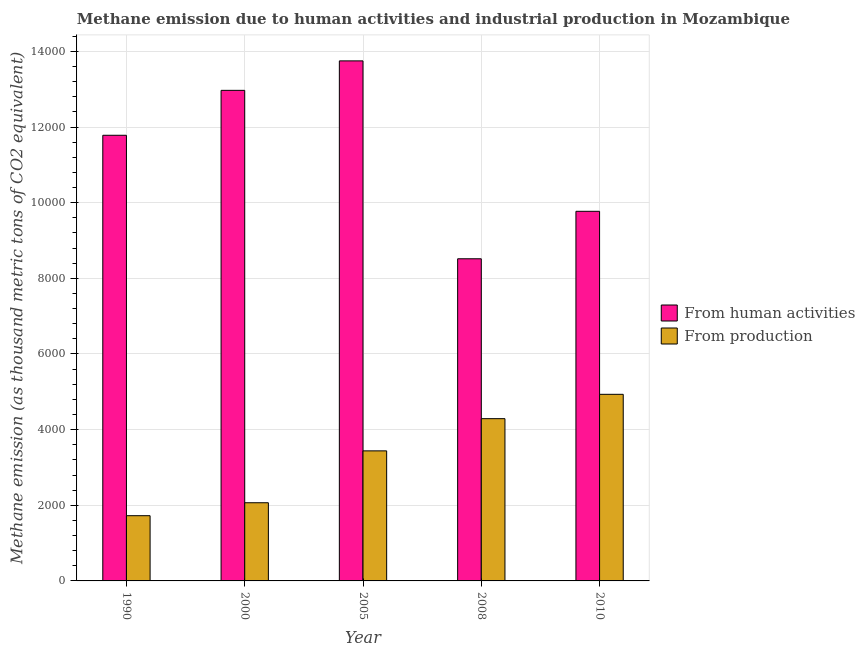How many different coloured bars are there?
Ensure brevity in your answer.  2. Are the number of bars per tick equal to the number of legend labels?
Your response must be concise. Yes. Are the number of bars on each tick of the X-axis equal?
Offer a terse response. Yes. How many bars are there on the 4th tick from the right?
Offer a very short reply. 2. In how many cases, is the number of bars for a given year not equal to the number of legend labels?
Your answer should be compact. 0. What is the amount of emissions from human activities in 1990?
Keep it short and to the point. 1.18e+04. Across all years, what is the maximum amount of emissions from human activities?
Offer a very short reply. 1.37e+04. Across all years, what is the minimum amount of emissions from human activities?
Provide a short and direct response. 8517.4. What is the total amount of emissions generated from industries in the graph?
Your response must be concise. 1.65e+04. What is the difference between the amount of emissions generated from industries in 1990 and that in 2008?
Provide a succinct answer. -2565.3. What is the difference between the amount of emissions from human activities in 2008 and the amount of emissions generated from industries in 2010?
Your answer should be very brief. -1255. What is the average amount of emissions from human activities per year?
Your answer should be very brief. 1.14e+04. In how many years, is the amount of emissions from human activities greater than 12000 thousand metric tons?
Provide a short and direct response. 2. What is the ratio of the amount of emissions from human activities in 1990 to that in 2008?
Provide a short and direct response. 1.38. Is the difference between the amount of emissions generated from industries in 2005 and 2010 greater than the difference between the amount of emissions from human activities in 2005 and 2010?
Your answer should be compact. No. What is the difference between the highest and the second highest amount of emissions from human activities?
Your answer should be very brief. 779.2. What is the difference between the highest and the lowest amount of emissions generated from industries?
Your response must be concise. 3208.8. In how many years, is the amount of emissions generated from industries greater than the average amount of emissions generated from industries taken over all years?
Your answer should be compact. 3. What does the 1st bar from the left in 1990 represents?
Your response must be concise. From human activities. What does the 2nd bar from the right in 2005 represents?
Offer a terse response. From human activities. How many years are there in the graph?
Make the answer very short. 5. What is the difference between two consecutive major ticks on the Y-axis?
Make the answer very short. 2000. Does the graph contain any zero values?
Your answer should be compact. No. How many legend labels are there?
Your answer should be compact. 2. What is the title of the graph?
Make the answer very short. Methane emission due to human activities and industrial production in Mozambique. Does "Subsidies" appear as one of the legend labels in the graph?
Make the answer very short. No. What is the label or title of the Y-axis?
Your response must be concise. Methane emission (as thousand metric tons of CO2 equivalent). What is the Methane emission (as thousand metric tons of CO2 equivalent) of From human activities in 1990?
Offer a very short reply. 1.18e+04. What is the Methane emission (as thousand metric tons of CO2 equivalent) of From production in 1990?
Provide a succinct answer. 1724.7. What is the Methane emission (as thousand metric tons of CO2 equivalent) in From human activities in 2000?
Offer a terse response. 1.30e+04. What is the Methane emission (as thousand metric tons of CO2 equivalent) of From production in 2000?
Your answer should be very brief. 2067.1. What is the Methane emission (as thousand metric tons of CO2 equivalent) in From human activities in 2005?
Your response must be concise. 1.37e+04. What is the Methane emission (as thousand metric tons of CO2 equivalent) of From production in 2005?
Offer a terse response. 3438.4. What is the Methane emission (as thousand metric tons of CO2 equivalent) of From human activities in 2008?
Offer a terse response. 8517.4. What is the Methane emission (as thousand metric tons of CO2 equivalent) in From production in 2008?
Provide a short and direct response. 4290. What is the Methane emission (as thousand metric tons of CO2 equivalent) in From human activities in 2010?
Offer a very short reply. 9772.4. What is the Methane emission (as thousand metric tons of CO2 equivalent) of From production in 2010?
Ensure brevity in your answer.  4933.5. Across all years, what is the maximum Methane emission (as thousand metric tons of CO2 equivalent) in From human activities?
Keep it short and to the point. 1.37e+04. Across all years, what is the maximum Methane emission (as thousand metric tons of CO2 equivalent) in From production?
Your response must be concise. 4933.5. Across all years, what is the minimum Methane emission (as thousand metric tons of CO2 equivalent) in From human activities?
Give a very brief answer. 8517.4. Across all years, what is the minimum Methane emission (as thousand metric tons of CO2 equivalent) of From production?
Provide a short and direct response. 1724.7. What is the total Methane emission (as thousand metric tons of CO2 equivalent) of From human activities in the graph?
Your answer should be compact. 5.68e+04. What is the total Methane emission (as thousand metric tons of CO2 equivalent) of From production in the graph?
Provide a succinct answer. 1.65e+04. What is the difference between the Methane emission (as thousand metric tons of CO2 equivalent) in From human activities in 1990 and that in 2000?
Offer a terse response. -1187.6. What is the difference between the Methane emission (as thousand metric tons of CO2 equivalent) of From production in 1990 and that in 2000?
Keep it short and to the point. -342.4. What is the difference between the Methane emission (as thousand metric tons of CO2 equivalent) in From human activities in 1990 and that in 2005?
Your response must be concise. -1966.8. What is the difference between the Methane emission (as thousand metric tons of CO2 equivalent) of From production in 1990 and that in 2005?
Offer a terse response. -1713.7. What is the difference between the Methane emission (as thousand metric tons of CO2 equivalent) in From human activities in 1990 and that in 2008?
Offer a very short reply. 3265.3. What is the difference between the Methane emission (as thousand metric tons of CO2 equivalent) in From production in 1990 and that in 2008?
Make the answer very short. -2565.3. What is the difference between the Methane emission (as thousand metric tons of CO2 equivalent) in From human activities in 1990 and that in 2010?
Offer a very short reply. 2010.3. What is the difference between the Methane emission (as thousand metric tons of CO2 equivalent) of From production in 1990 and that in 2010?
Your answer should be compact. -3208.8. What is the difference between the Methane emission (as thousand metric tons of CO2 equivalent) of From human activities in 2000 and that in 2005?
Your answer should be very brief. -779.2. What is the difference between the Methane emission (as thousand metric tons of CO2 equivalent) of From production in 2000 and that in 2005?
Make the answer very short. -1371.3. What is the difference between the Methane emission (as thousand metric tons of CO2 equivalent) of From human activities in 2000 and that in 2008?
Ensure brevity in your answer.  4452.9. What is the difference between the Methane emission (as thousand metric tons of CO2 equivalent) of From production in 2000 and that in 2008?
Provide a short and direct response. -2222.9. What is the difference between the Methane emission (as thousand metric tons of CO2 equivalent) of From human activities in 2000 and that in 2010?
Offer a terse response. 3197.9. What is the difference between the Methane emission (as thousand metric tons of CO2 equivalent) in From production in 2000 and that in 2010?
Your response must be concise. -2866.4. What is the difference between the Methane emission (as thousand metric tons of CO2 equivalent) in From human activities in 2005 and that in 2008?
Your answer should be compact. 5232.1. What is the difference between the Methane emission (as thousand metric tons of CO2 equivalent) of From production in 2005 and that in 2008?
Provide a succinct answer. -851.6. What is the difference between the Methane emission (as thousand metric tons of CO2 equivalent) in From human activities in 2005 and that in 2010?
Ensure brevity in your answer.  3977.1. What is the difference between the Methane emission (as thousand metric tons of CO2 equivalent) in From production in 2005 and that in 2010?
Give a very brief answer. -1495.1. What is the difference between the Methane emission (as thousand metric tons of CO2 equivalent) in From human activities in 2008 and that in 2010?
Make the answer very short. -1255. What is the difference between the Methane emission (as thousand metric tons of CO2 equivalent) in From production in 2008 and that in 2010?
Your response must be concise. -643.5. What is the difference between the Methane emission (as thousand metric tons of CO2 equivalent) of From human activities in 1990 and the Methane emission (as thousand metric tons of CO2 equivalent) of From production in 2000?
Give a very brief answer. 9715.6. What is the difference between the Methane emission (as thousand metric tons of CO2 equivalent) of From human activities in 1990 and the Methane emission (as thousand metric tons of CO2 equivalent) of From production in 2005?
Ensure brevity in your answer.  8344.3. What is the difference between the Methane emission (as thousand metric tons of CO2 equivalent) of From human activities in 1990 and the Methane emission (as thousand metric tons of CO2 equivalent) of From production in 2008?
Offer a terse response. 7492.7. What is the difference between the Methane emission (as thousand metric tons of CO2 equivalent) of From human activities in 1990 and the Methane emission (as thousand metric tons of CO2 equivalent) of From production in 2010?
Ensure brevity in your answer.  6849.2. What is the difference between the Methane emission (as thousand metric tons of CO2 equivalent) in From human activities in 2000 and the Methane emission (as thousand metric tons of CO2 equivalent) in From production in 2005?
Provide a short and direct response. 9531.9. What is the difference between the Methane emission (as thousand metric tons of CO2 equivalent) of From human activities in 2000 and the Methane emission (as thousand metric tons of CO2 equivalent) of From production in 2008?
Offer a terse response. 8680.3. What is the difference between the Methane emission (as thousand metric tons of CO2 equivalent) in From human activities in 2000 and the Methane emission (as thousand metric tons of CO2 equivalent) in From production in 2010?
Give a very brief answer. 8036.8. What is the difference between the Methane emission (as thousand metric tons of CO2 equivalent) in From human activities in 2005 and the Methane emission (as thousand metric tons of CO2 equivalent) in From production in 2008?
Ensure brevity in your answer.  9459.5. What is the difference between the Methane emission (as thousand metric tons of CO2 equivalent) in From human activities in 2005 and the Methane emission (as thousand metric tons of CO2 equivalent) in From production in 2010?
Your response must be concise. 8816. What is the difference between the Methane emission (as thousand metric tons of CO2 equivalent) of From human activities in 2008 and the Methane emission (as thousand metric tons of CO2 equivalent) of From production in 2010?
Keep it short and to the point. 3583.9. What is the average Methane emission (as thousand metric tons of CO2 equivalent) in From human activities per year?
Your answer should be compact. 1.14e+04. What is the average Methane emission (as thousand metric tons of CO2 equivalent) in From production per year?
Your answer should be very brief. 3290.74. In the year 1990, what is the difference between the Methane emission (as thousand metric tons of CO2 equivalent) in From human activities and Methane emission (as thousand metric tons of CO2 equivalent) in From production?
Offer a very short reply. 1.01e+04. In the year 2000, what is the difference between the Methane emission (as thousand metric tons of CO2 equivalent) in From human activities and Methane emission (as thousand metric tons of CO2 equivalent) in From production?
Your response must be concise. 1.09e+04. In the year 2005, what is the difference between the Methane emission (as thousand metric tons of CO2 equivalent) in From human activities and Methane emission (as thousand metric tons of CO2 equivalent) in From production?
Offer a terse response. 1.03e+04. In the year 2008, what is the difference between the Methane emission (as thousand metric tons of CO2 equivalent) in From human activities and Methane emission (as thousand metric tons of CO2 equivalent) in From production?
Make the answer very short. 4227.4. In the year 2010, what is the difference between the Methane emission (as thousand metric tons of CO2 equivalent) of From human activities and Methane emission (as thousand metric tons of CO2 equivalent) of From production?
Keep it short and to the point. 4838.9. What is the ratio of the Methane emission (as thousand metric tons of CO2 equivalent) of From human activities in 1990 to that in 2000?
Keep it short and to the point. 0.91. What is the ratio of the Methane emission (as thousand metric tons of CO2 equivalent) in From production in 1990 to that in 2000?
Your response must be concise. 0.83. What is the ratio of the Methane emission (as thousand metric tons of CO2 equivalent) in From human activities in 1990 to that in 2005?
Offer a very short reply. 0.86. What is the ratio of the Methane emission (as thousand metric tons of CO2 equivalent) of From production in 1990 to that in 2005?
Ensure brevity in your answer.  0.5. What is the ratio of the Methane emission (as thousand metric tons of CO2 equivalent) in From human activities in 1990 to that in 2008?
Offer a terse response. 1.38. What is the ratio of the Methane emission (as thousand metric tons of CO2 equivalent) of From production in 1990 to that in 2008?
Offer a very short reply. 0.4. What is the ratio of the Methane emission (as thousand metric tons of CO2 equivalent) of From human activities in 1990 to that in 2010?
Make the answer very short. 1.21. What is the ratio of the Methane emission (as thousand metric tons of CO2 equivalent) in From production in 1990 to that in 2010?
Your answer should be very brief. 0.35. What is the ratio of the Methane emission (as thousand metric tons of CO2 equivalent) of From human activities in 2000 to that in 2005?
Offer a terse response. 0.94. What is the ratio of the Methane emission (as thousand metric tons of CO2 equivalent) of From production in 2000 to that in 2005?
Your answer should be very brief. 0.6. What is the ratio of the Methane emission (as thousand metric tons of CO2 equivalent) of From human activities in 2000 to that in 2008?
Your answer should be compact. 1.52. What is the ratio of the Methane emission (as thousand metric tons of CO2 equivalent) in From production in 2000 to that in 2008?
Offer a very short reply. 0.48. What is the ratio of the Methane emission (as thousand metric tons of CO2 equivalent) in From human activities in 2000 to that in 2010?
Keep it short and to the point. 1.33. What is the ratio of the Methane emission (as thousand metric tons of CO2 equivalent) of From production in 2000 to that in 2010?
Make the answer very short. 0.42. What is the ratio of the Methane emission (as thousand metric tons of CO2 equivalent) of From human activities in 2005 to that in 2008?
Make the answer very short. 1.61. What is the ratio of the Methane emission (as thousand metric tons of CO2 equivalent) in From production in 2005 to that in 2008?
Your response must be concise. 0.8. What is the ratio of the Methane emission (as thousand metric tons of CO2 equivalent) in From human activities in 2005 to that in 2010?
Give a very brief answer. 1.41. What is the ratio of the Methane emission (as thousand metric tons of CO2 equivalent) of From production in 2005 to that in 2010?
Ensure brevity in your answer.  0.7. What is the ratio of the Methane emission (as thousand metric tons of CO2 equivalent) of From human activities in 2008 to that in 2010?
Provide a succinct answer. 0.87. What is the ratio of the Methane emission (as thousand metric tons of CO2 equivalent) of From production in 2008 to that in 2010?
Your answer should be compact. 0.87. What is the difference between the highest and the second highest Methane emission (as thousand metric tons of CO2 equivalent) in From human activities?
Ensure brevity in your answer.  779.2. What is the difference between the highest and the second highest Methane emission (as thousand metric tons of CO2 equivalent) in From production?
Offer a very short reply. 643.5. What is the difference between the highest and the lowest Methane emission (as thousand metric tons of CO2 equivalent) in From human activities?
Your response must be concise. 5232.1. What is the difference between the highest and the lowest Methane emission (as thousand metric tons of CO2 equivalent) in From production?
Offer a terse response. 3208.8. 